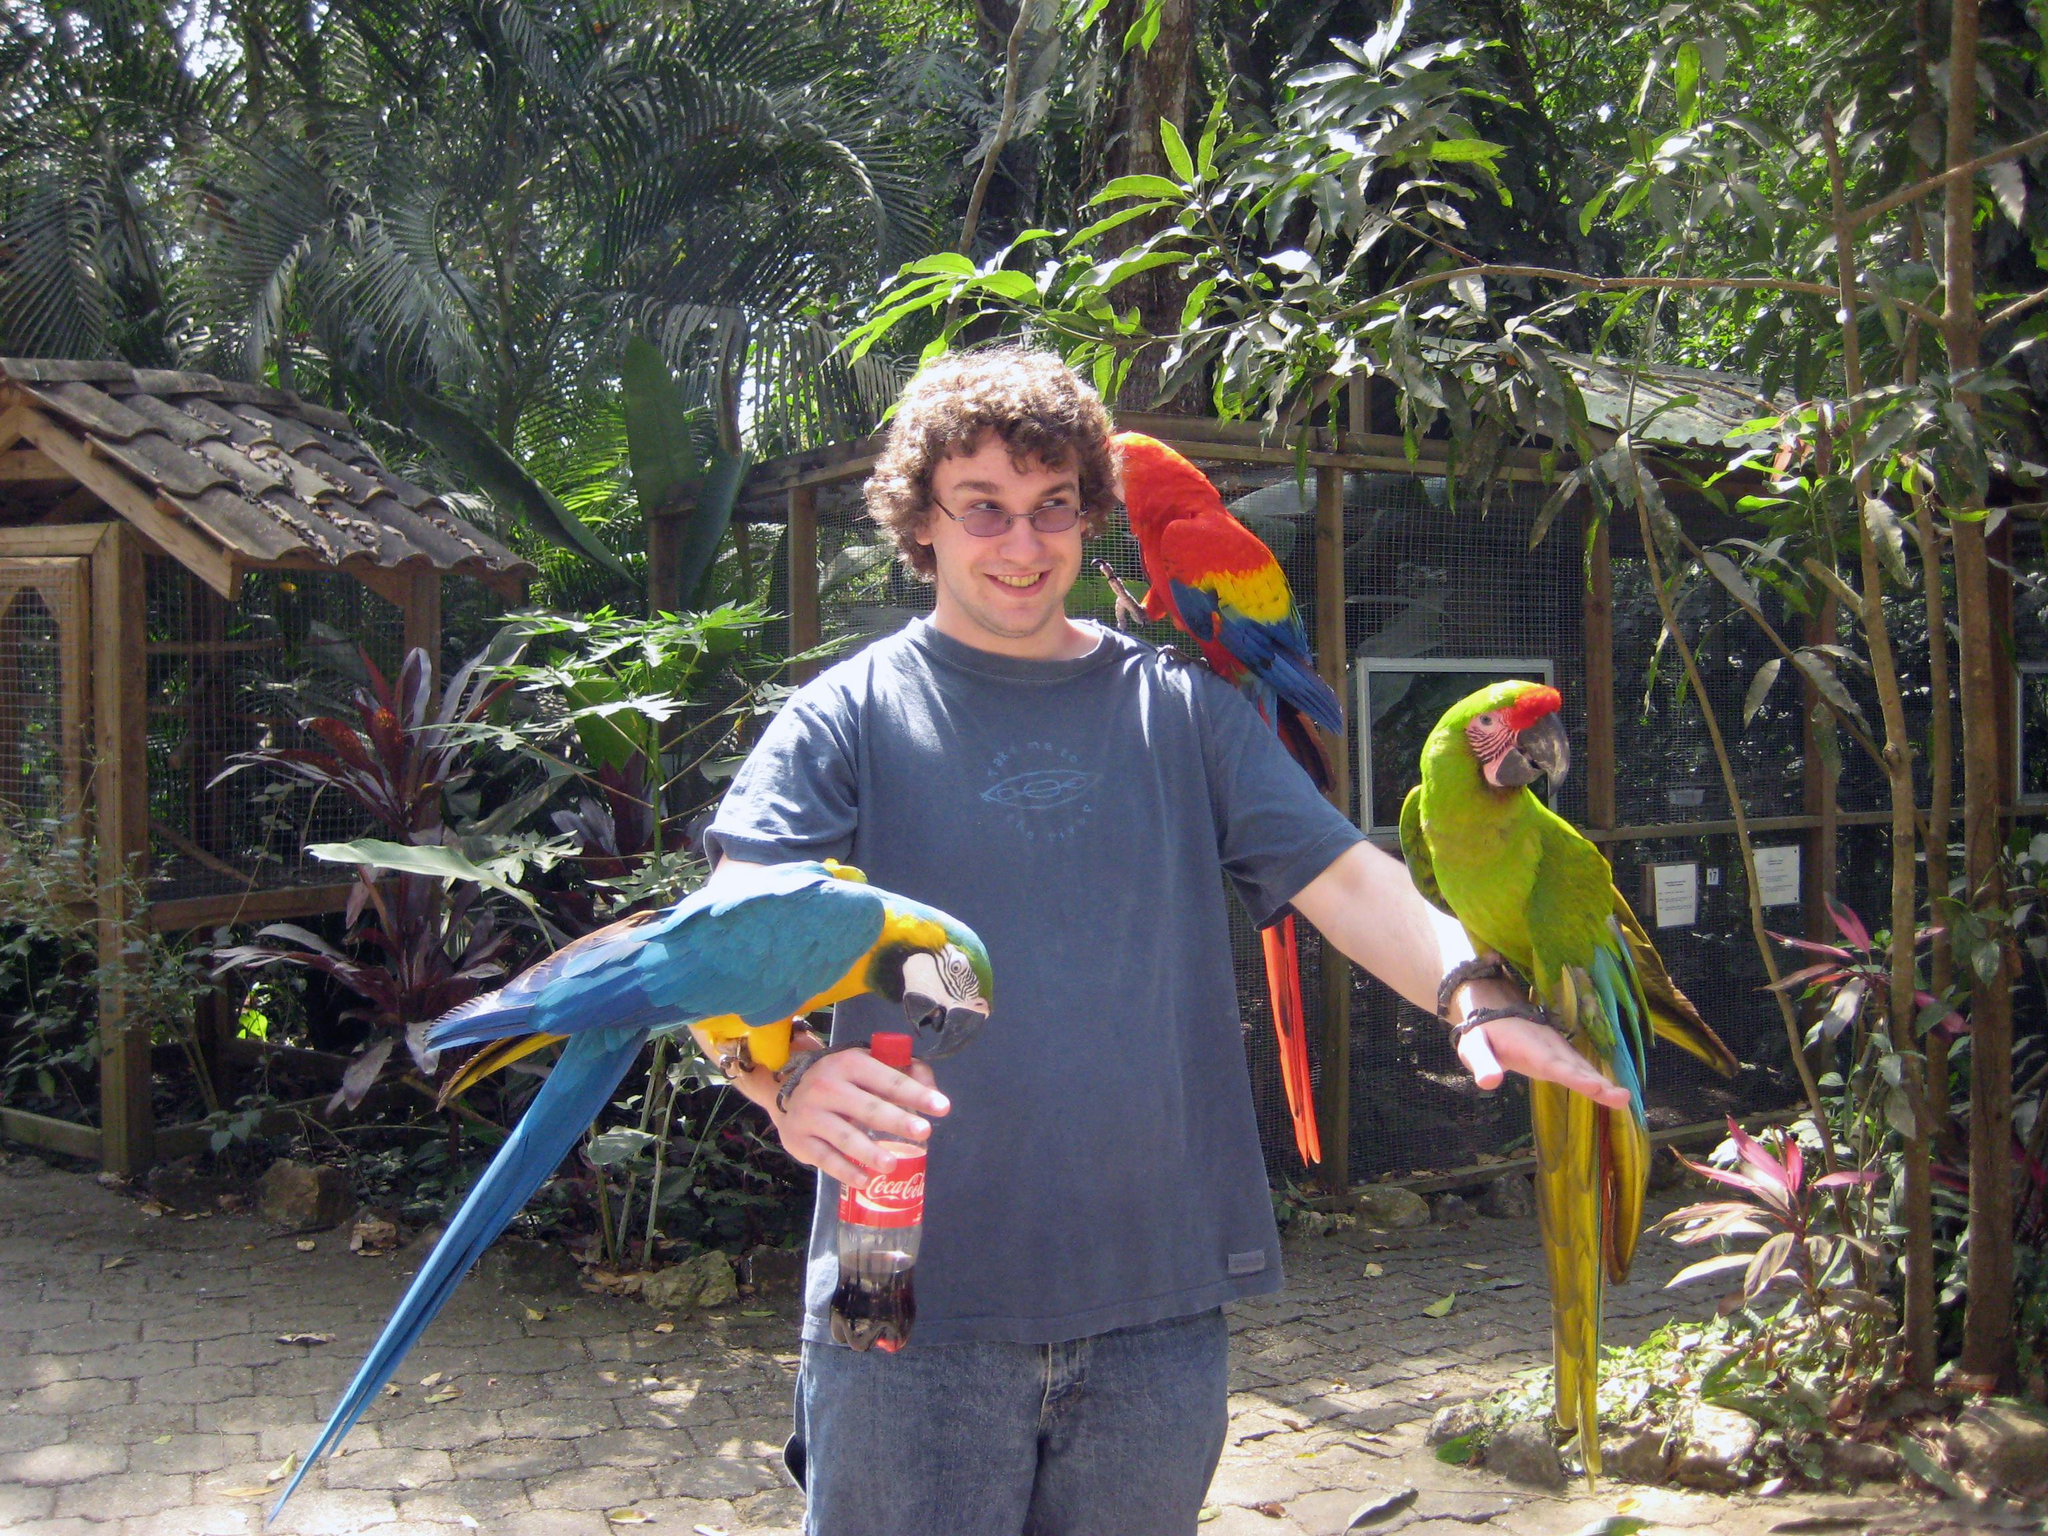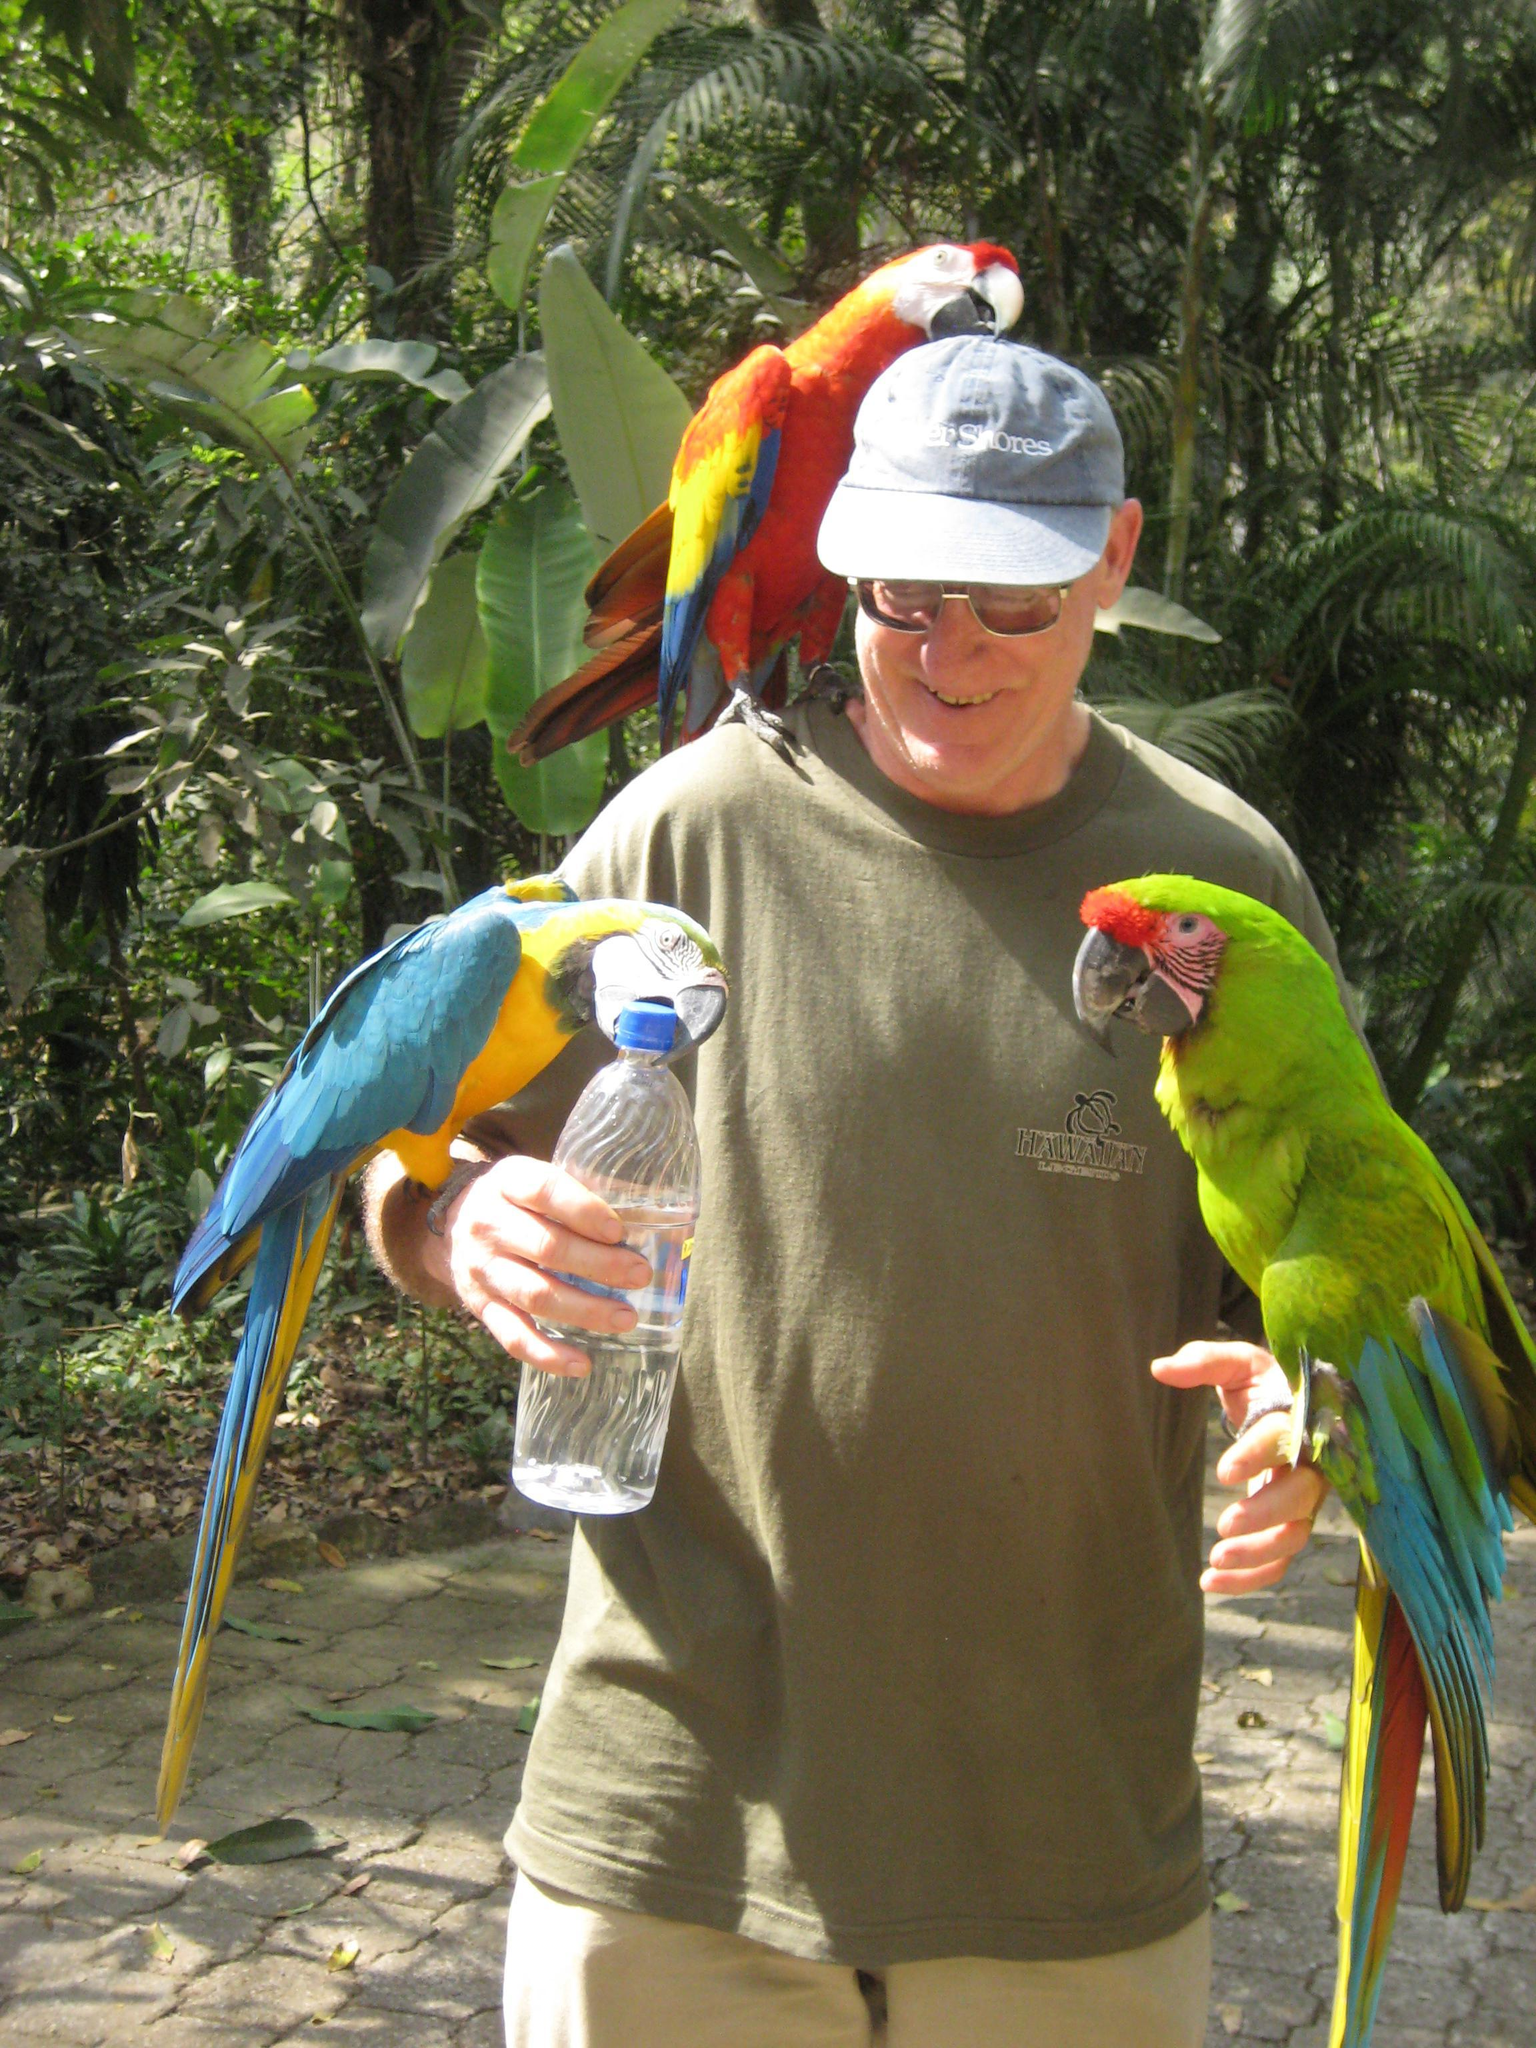The first image is the image on the left, the second image is the image on the right. Considering the images on both sides, is "In one image, a person is standing in front of a roofed and screened cage area with three different colored parrots perched them." valid? Answer yes or no. Yes. The first image is the image on the left, the second image is the image on the right. For the images displayed, is the sentence "At least one image shows a person with three parrots perched somewhere on their body." factually correct? Answer yes or no. Yes. 